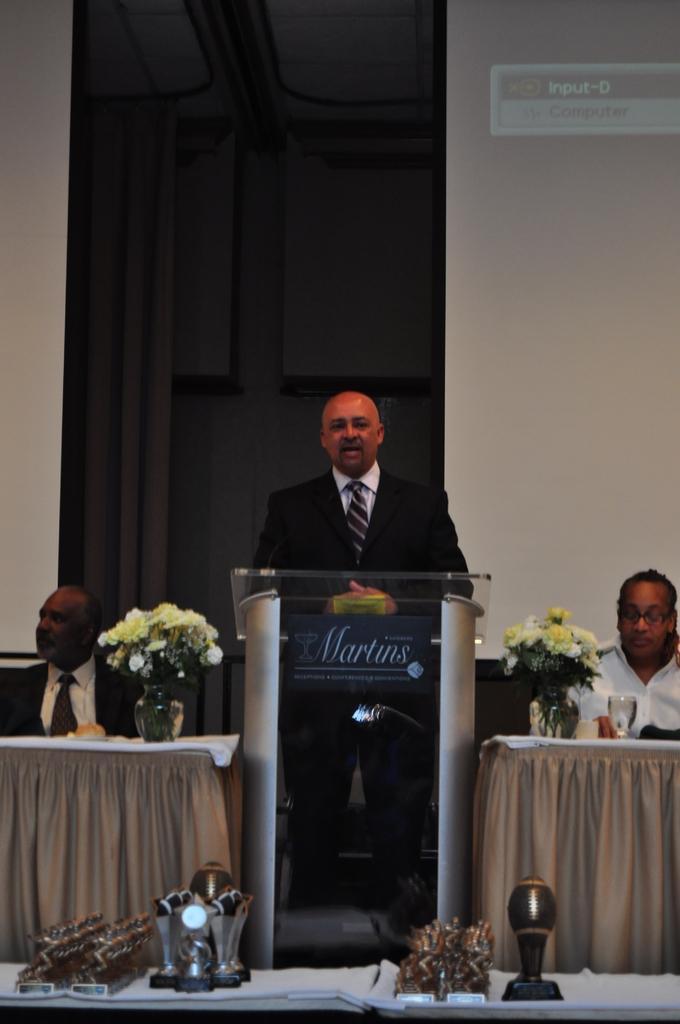In one or two sentences, can you explain what this image depicts? A man is standing and speaking at a podium. There are two men on either side of him sitting at a table. There two flower bouquets beside them. 